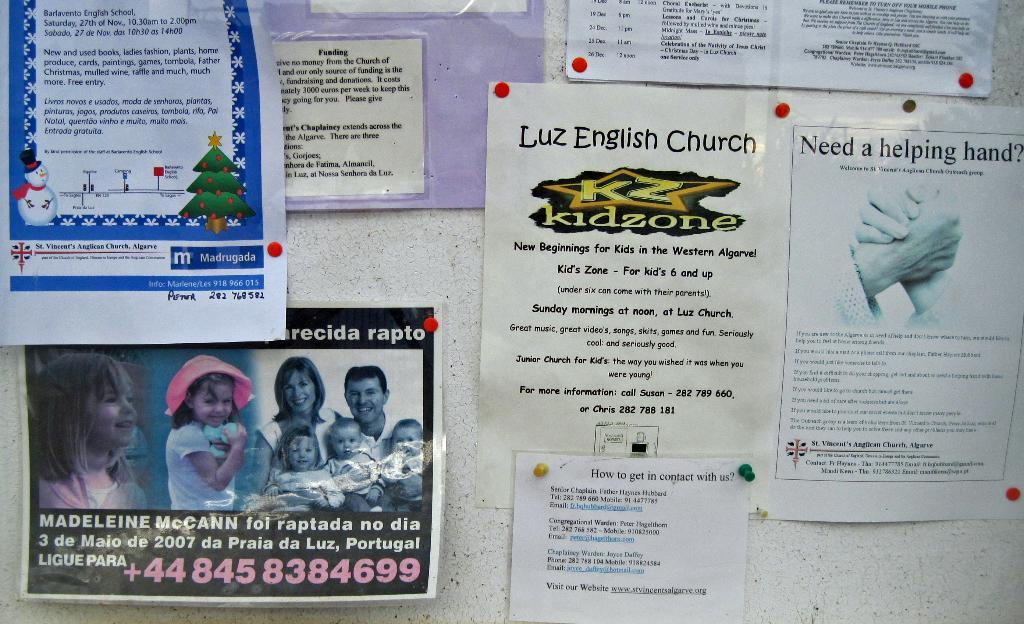<image>
Provide a brief description of the given image. A bulletin board including flyers for the Luz English Church kidzone and other things. 